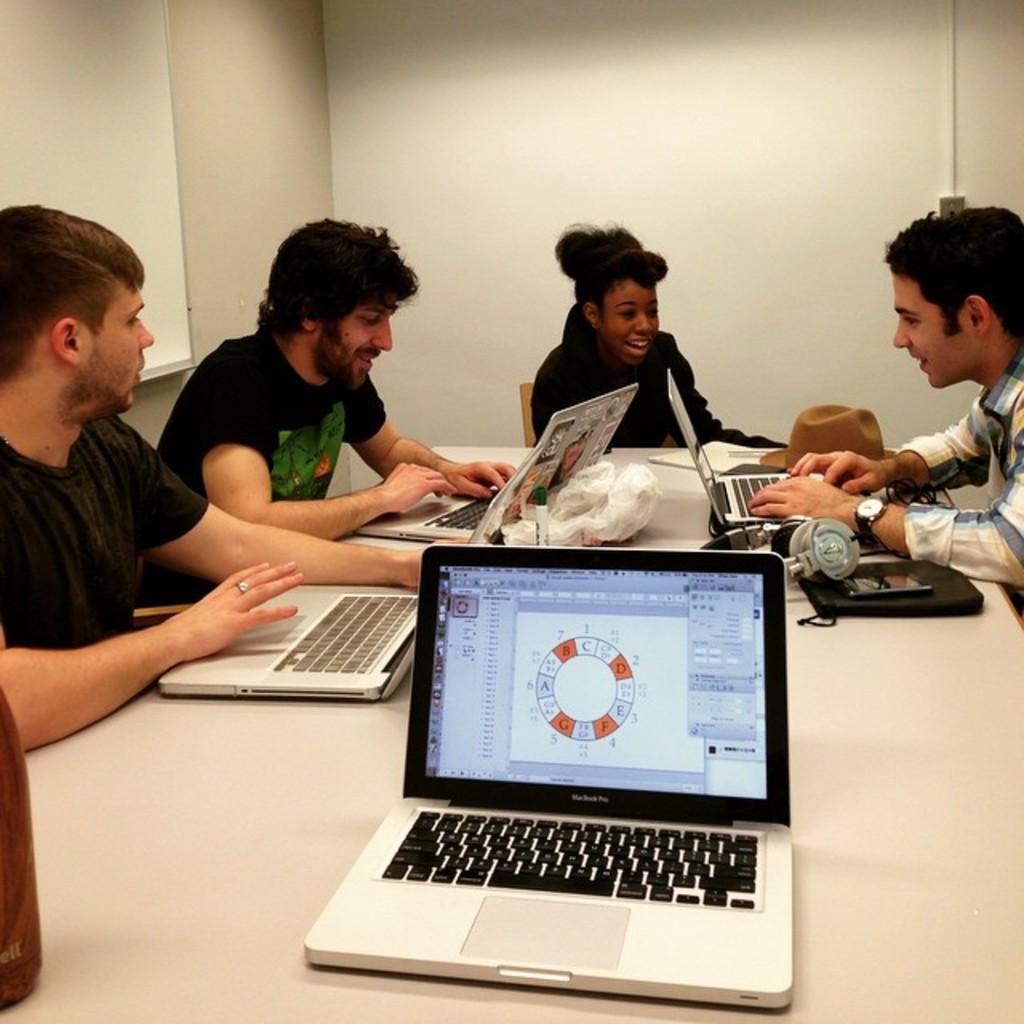Could you give a brief overview of what you see in this image? People are sitting on the the chair near the table and on the table laptop,headphones are present. 